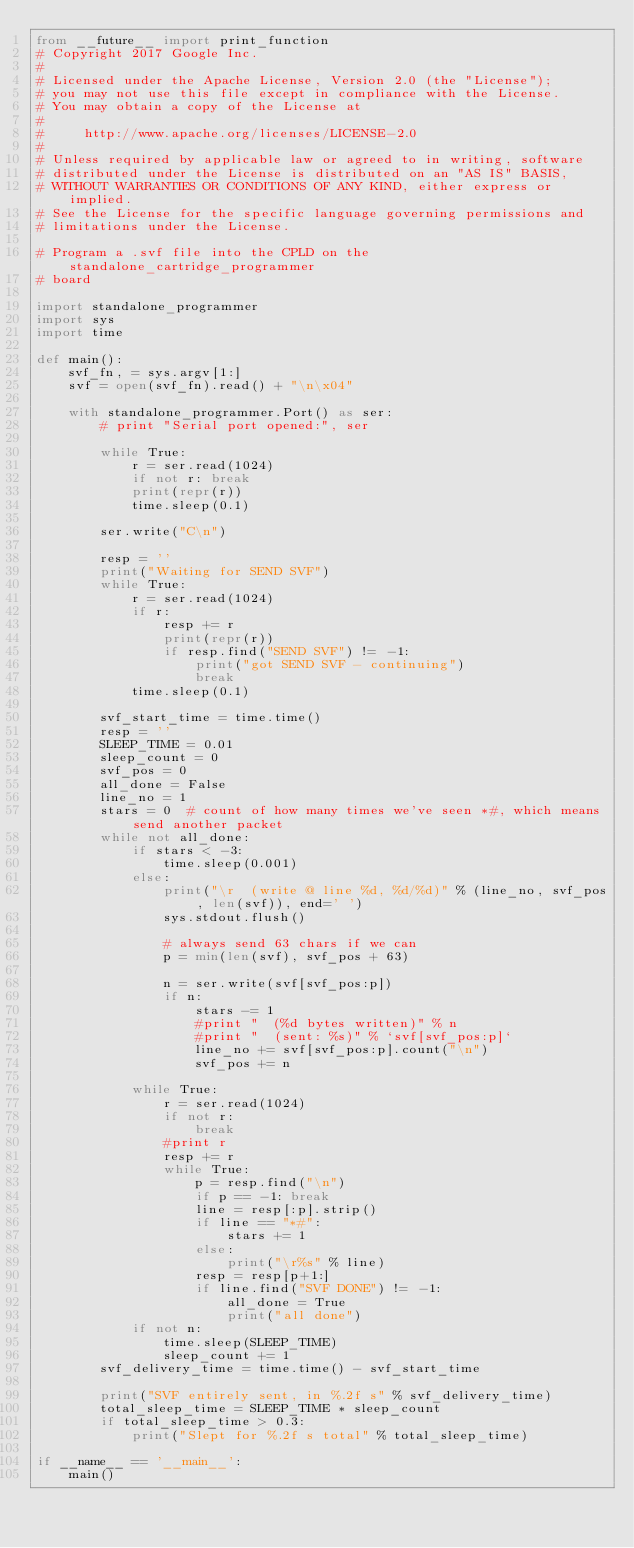Convert code to text. <code><loc_0><loc_0><loc_500><loc_500><_Python_>from __future__ import print_function
# Copyright 2017 Google Inc.
#
# Licensed under the Apache License, Version 2.0 (the "License");
# you may not use this file except in compliance with the License.
# You may obtain a copy of the License at
#
#     http://www.apache.org/licenses/LICENSE-2.0
#
# Unless required by applicable law or agreed to in writing, software
# distributed under the License is distributed on an "AS IS" BASIS,
# WITHOUT WARRANTIES OR CONDITIONS OF ANY KIND, either express or implied.
# See the License for the specific language governing permissions and
# limitations under the License.

# Program a .svf file into the CPLD on the standalone_cartridge_programmer
# board

import standalone_programmer
import sys
import time

def main():
    svf_fn, = sys.argv[1:]
    svf = open(svf_fn).read() + "\n\x04"

    with standalone_programmer.Port() as ser:
        # print "Serial port opened:", ser

        while True:
            r = ser.read(1024)
            if not r: break
            print(repr(r))
            time.sleep(0.1)

        ser.write("C\n")

        resp = ''
        print("Waiting for SEND SVF")
        while True:
            r = ser.read(1024)
            if r:
                resp += r
                print(repr(r))
                if resp.find("SEND SVF") != -1:
                    print("got SEND SVF - continuing")
                    break
            time.sleep(0.1)

        svf_start_time = time.time()
        resp = ''
        SLEEP_TIME = 0.01
        sleep_count = 0
        svf_pos = 0
        all_done = False
        line_no = 1
        stars = 0  # count of how many times we've seen *#, which means send another packet
        while not all_done:
            if stars < -3:
                time.sleep(0.001)
            else:
                print("\r  (write @ line %d, %d/%d)" % (line_no, svf_pos, len(svf)), end=' ')
                sys.stdout.flush()

                # always send 63 chars if we can
                p = min(len(svf), svf_pos + 63)

                n = ser.write(svf[svf_pos:p])
                if n:
                    stars -= 1
                    #print "  (%d bytes written)" % n
                    #print "  (sent: %s)" % `svf[svf_pos:p]`
                    line_no += svf[svf_pos:p].count("\n")
                    svf_pos += n

            while True:
                r = ser.read(1024)
                if not r:
                    break
                #print r
                resp += r
                while True:
                    p = resp.find("\n")
                    if p == -1: break
                    line = resp[:p].strip()
                    if line == "*#":
                        stars += 1
                    else:
                        print("\r%s" % line)
                    resp = resp[p+1:]
                    if line.find("SVF DONE") != -1:
                        all_done = True
                        print("all done")
            if not n:
                time.sleep(SLEEP_TIME)
                sleep_count += 1
        svf_delivery_time = time.time() - svf_start_time

        print("SVF entirely sent, in %.2f s" % svf_delivery_time)
        total_sleep_time = SLEEP_TIME * sleep_count
        if total_sleep_time > 0.3:
            print("Slept for %.2f s total" % total_sleep_time)

if __name__ == '__main__':
    main()
</code> 